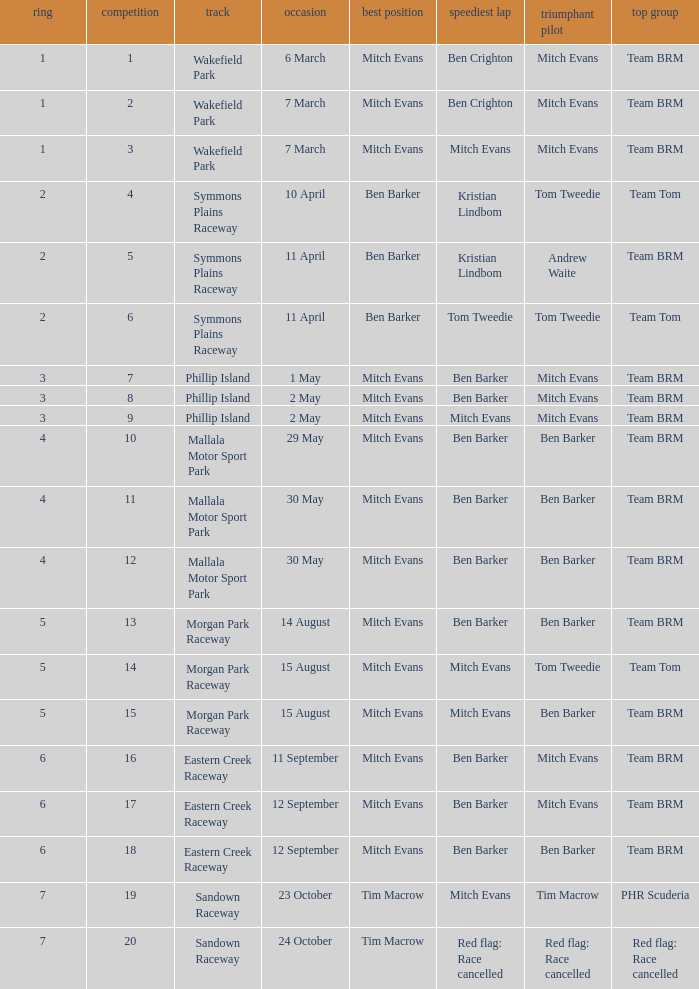What team won Race 17? Team BRM. 